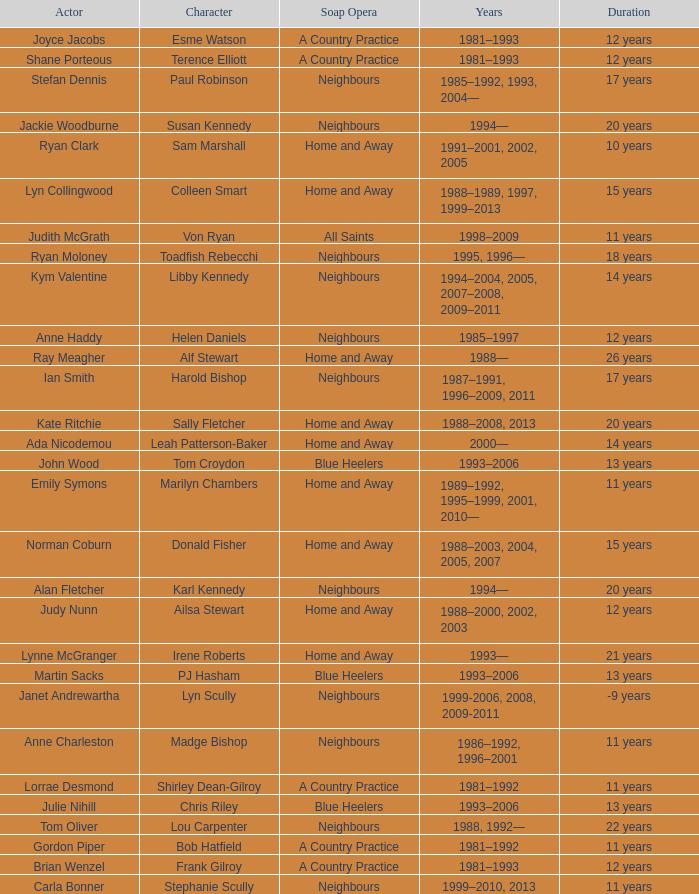Which years did Martin Sacks work on a soap opera? 1993–2006. Parse the table in full. {'header': ['Actor', 'Character', 'Soap Opera', 'Years', 'Duration'], 'rows': [['Joyce Jacobs', 'Esme Watson', 'A Country Practice', '1981–1993', '12 years'], ['Shane Porteous', 'Terence Elliott', 'A Country Practice', '1981–1993', '12 years'], ['Stefan Dennis', 'Paul Robinson', 'Neighbours', '1985–1992, 1993, 2004—', '17 years'], ['Jackie Woodburne', 'Susan Kennedy', 'Neighbours', '1994—', '20 years'], ['Ryan Clark', 'Sam Marshall', 'Home and Away', '1991–2001, 2002, 2005', '10 years'], ['Lyn Collingwood', 'Colleen Smart', 'Home and Away', '1988–1989, 1997, 1999–2013', '15 years'], ['Judith McGrath', 'Von Ryan', 'All Saints', '1998–2009', '11 years'], ['Ryan Moloney', 'Toadfish Rebecchi', 'Neighbours', '1995, 1996—', '18 years'], ['Kym Valentine', 'Libby Kennedy', 'Neighbours', '1994–2004, 2005, 2007–2008, 2009–2011', '14 years'], ['Anne Haddy', 'Helen Daniels', 'Neighbours', '1985–1997', '12 years'], ['Ray Meagher', 'Alf Stewart', 'Home and Away', '1988—', '26 years'], ['Ian Smith', 'Harold Bishop', 'Neighbours', '1987–1991, 1996–2009, 2011', '17 years'], ['Kate Ritchie', 'Sally Fletcher', 'Home and Away', '1988–2008, 2013', '20 years'], ['Ada Nicodemou', 'Leah Patterson-Baker', 'Home and Away', '2000—', '14 years'], ['John Wood', 'Tom Croydon', 'Blue Heelers', '1993–2006', '13 years'], ['Emily Symons', 'Marilyn Chambers', 'Home and Away', '1989–1992, 1995–1999, 2001, 2010—', '11 years'], ['Norman Coburn', 'Donald Fisher', 'Home and Away', '1988–2003, 2004, 2005, 2007', '15 years'], ['Alan Fletcher', 'Karl Kennedy', 'Neighbours', '1994—', '20 years'], ['Judy Nunn', 'Ailsa Stewart', 'Home and Away', '1988–2000, 2002, 2003', '12 years'], ['Lynne McGranger', 'Irene Roberts', 'Home and Away', '1993—', '21 years'], ['Martin Sacks', 'PJ Hasham', 'Blue Heelers', '1993–2006', '13 years'], ['Janet Andrewartha', 'Lyn Scully', 'Neighbours', '1999-2006, 2008, 2009-2011', '-9 years'], ['Anne Charleston', 'Madge Bishop', 'Neighbours', '1986–1992, 1996–2001', '11 years'], ['Lorrae Desmond', 'Shirley Dean-Gilroy', 'A Country Practice', '1981–1992', '11 years'], ['Julie Nihill', 'Chris Riley', 'Blue Heelers', '1993–2006', '13 years'], ['Tom Oliver', 'Lou Carpenter', 'Neighbours', '1988, 1992—', '22 years'], ['Gordon Piper', 'Bob Hatfield', 'A Country Practice', '1981–1992', '11 years'], ['Brian Wenzel', 'Frank Gilroy', 'A Country Practice', '1981–1993', '12 years'], ['Carla Bonner', 'Stephanie Scully', 'Neighbours', '1999–2010, 2013', '11 years']]} 